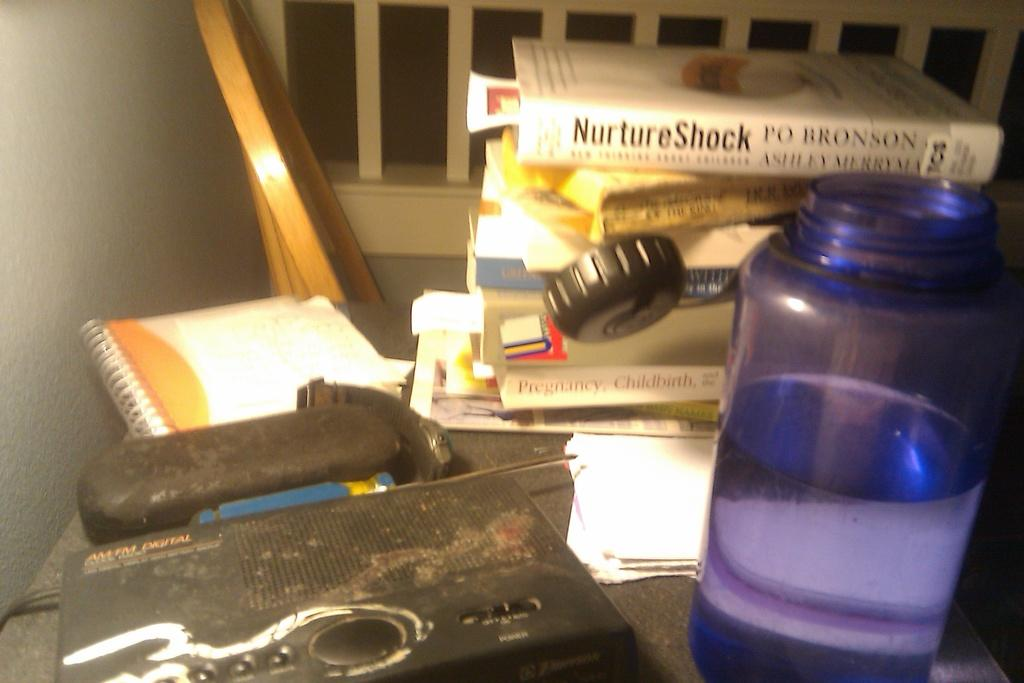Provide a one-sentence caption for the provided image. A collection of books including NurtureShock by Po Bronson. 